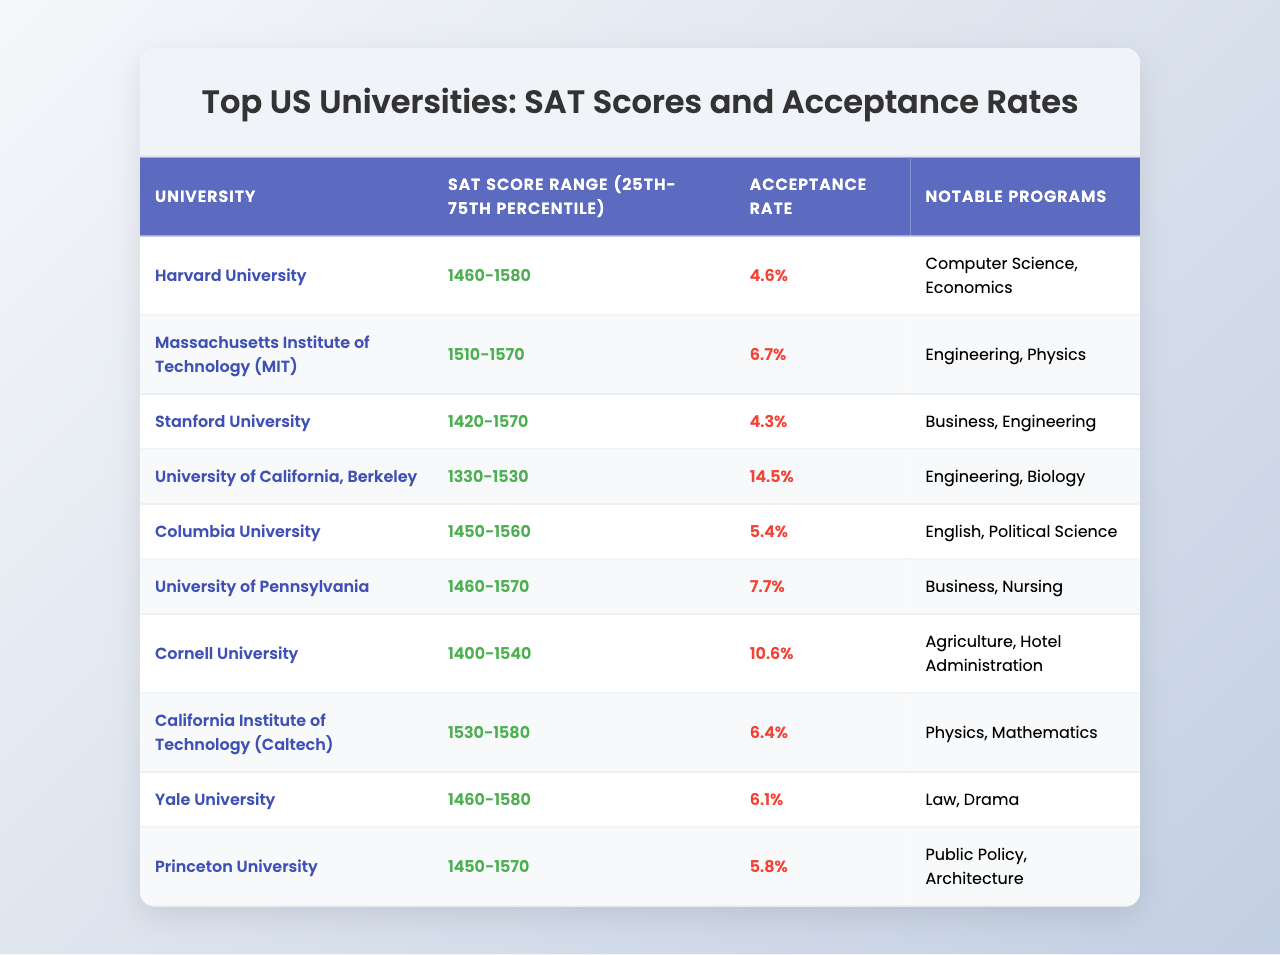What is the SAT score range for Harvard University? The table explicitly lists the SAT score range for Harvard University as "1460-1580".
Answer: 1460-1580 Which university has the highest acceptance rate? By comparing the acceptance rates in the table, the University of California, Berkeley has the highest acceptance rate at 14.5%.
Answer: University of California, Berkeley Is the acceptance rate for Stanford University less than 5%? The acceptance rate for Stanford University is given as 4.3%, which is indeed less than 5%.
Answer: Yes What are the notable programs offered by Massachusetts Institute of Technology (MIT)? The table lists Engineering and Physics as the notable programs for MIT.
Answer: Engineering, Physics Which universities have an SAT score range above 1500? From the table, the universities with an SAT score range above 1500 are: MIT, Caltech, and Yale.
Answer: MIT, Caltech, Yale What is the difference in acceptance rates between Harvard University and Columbia University? Harvard's acceptance rate is 4.6% and Columbia's is 5.4%. The difference is 5.4% - 4.6% = 0.8%.
Answer: 0.8% What is the average SAT score range for the given universities? To find the average, we must convert the ranges to numerical values. The midpoint for each range can be calculated: Harvard (1490), MIT (1540), Stanford (1495), Berkeley (1430), Columbia (1505), Penn (1515), Cornell (1470), Caltech (1555), Yale (1520), and Princeton (1510). Then sum these midpoints and divide by 10. The average is approximately 1496.
Answer: Approximately 1496 How many universities have notable programs in Engineering? By checking the table, we see that MIT, Caltech, and Berkeley have notable programs in Engineering, totaling three universities.
Answer: 3 Can you list the universities with an SAT score range that starts with 14XX? The universities with an SAT score range starting with 14XX are Harvard, Stanford, Columbia, Penn, and Princeton.
Answer: Harvard, Stanford, Columbia, Penn, Princeton Is Yale University’s SAT score range higher than that of Cornell University? Yale's SAT score range is 1460-1580 while Cornell's is 1400-1540. Since Yale's lower bound (1460) is higher than Cornell's upper bound (1540), it indicates that Yale’s range is indeed higher.
Answer: Yes 